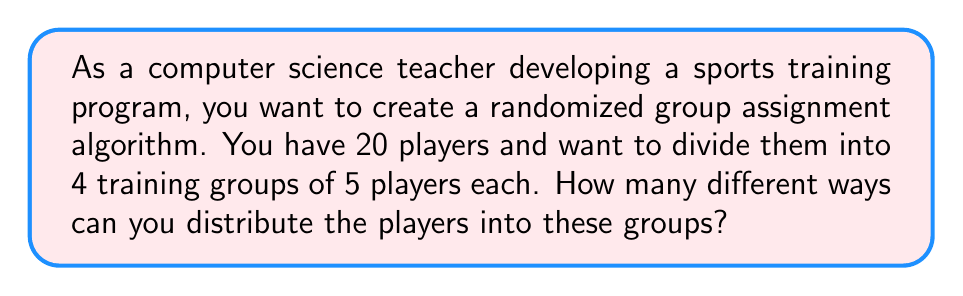Could you help me with this problem? To solve this problem, we need to use the concept of partitions in combinatorics. This is a perfect application for the "Stars and Bars" method, which is often used in computer science for distributing objects into groups.

1) First, we need to recognize that this is equivalent to choosing 3 dividers to separate the 20 players into 4 groups. The order of players within each group doesn't matter, and the order of the groups doesn't matter.

2) This scenario can be represented by the following formula:

   $$\binom{n-1}{k-1}$$

   where $n$ is the total number of players and $k$ is the number of groups.

3) In our case, $n = 20$ and $k = 4$. So we need to calculate:

   $$\binom{20-1}{4-1} = \binom{19}{3}$$

4) The formula for this combination is:

   $$\binom{19}{3} = \frac{19!}{3!(19-3)!} = \frac{19!}{3!16!}$$

5) Expanding this:
   
   $$\frac{19 * 18 * 17 * 16!}{(3 * 2 * 1) * 16!}$$

6) The 16! cancels out in the numerator and denominator:

   $$\frac{19 * 18 * 17}{3 * 2 * 1} = \frac{5814}{6} = 969$$

Therefore, there are 969 different ways to distribute 20 players into 4 groups of 5 players each.

This solution can be implemented in a programming language to automate the process of group assignments, demonstrating the intersection of combinatorics and computer science in sports training applications.
Answer: 969 